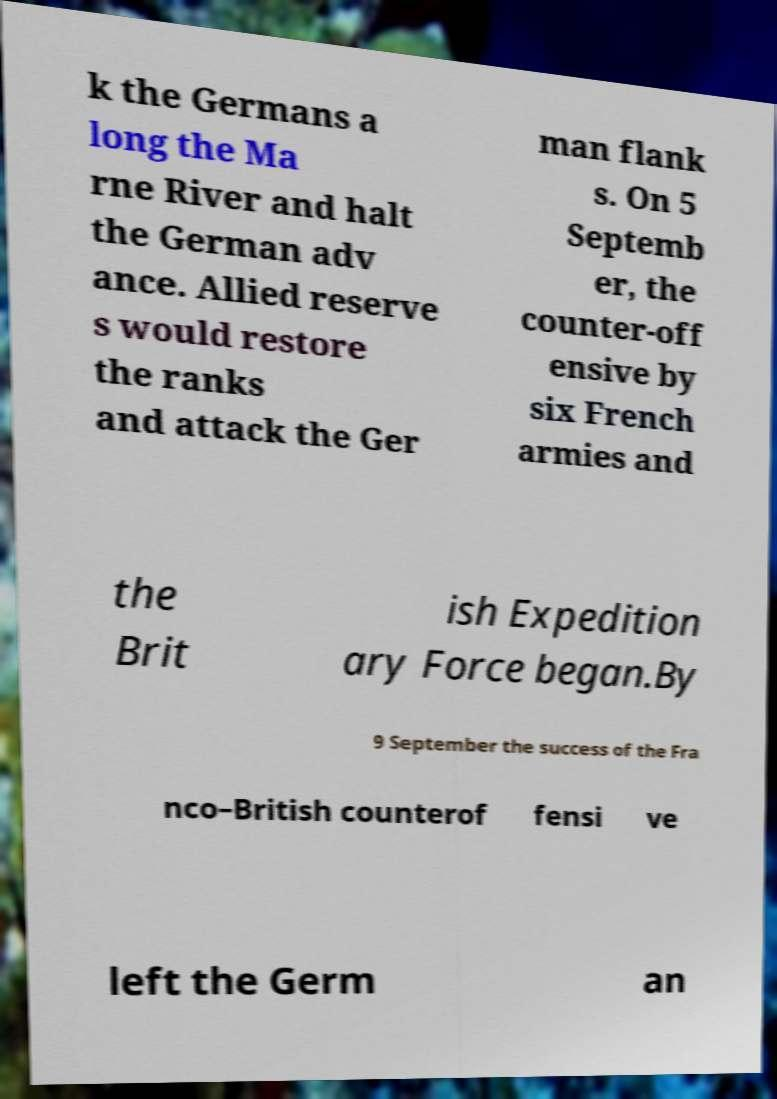Can you read and provide the text displayed in the image?This photo seems to have some interesting text. Can you extract and type it out for me? k the Germans a long the Ma rne River and halt the German adv ance. Allied reserve s would restore the ranks and attack the Ger man flank s. On 5 Septemb er, the counter-off ensive by six French armies and the Brit ish Expedition ary Force began.By 9 September the success of the Fra nco–British counterof fensi ve left the Germ an 